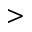Convert formula to latex. <formula><loc_0><loc_0><loc_500><loc_500>></formula> 